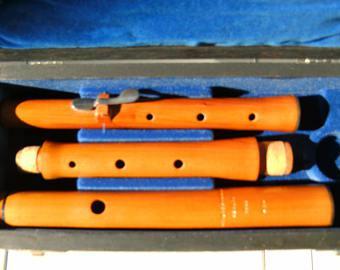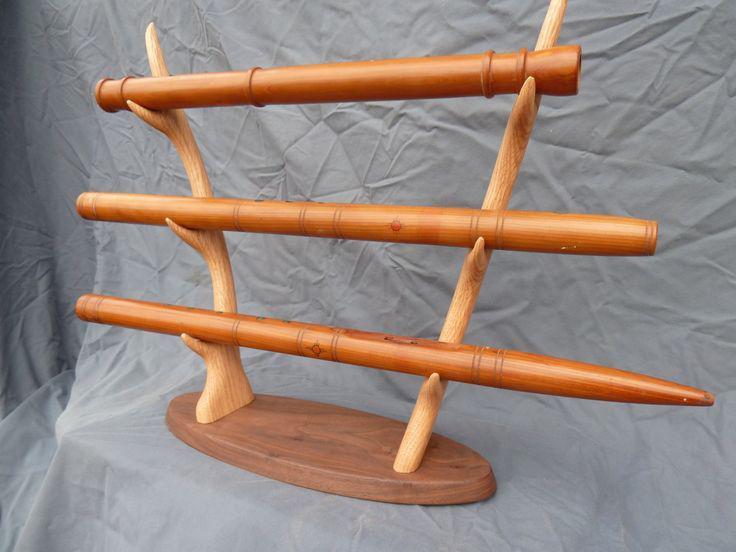The first image is the image on the left, the second image is the image on the right. Examine the images to the left and right. Is the description "In the right image, the instruments are displayed horizontally." accurate? Answer yes or no. Yes. The first image is the image on the left, the second image is the image on the right. Assess this claim about the two images: "In the image to the right, three parts of a flute are held horizontally.". Correct or not? Answer yes or no. Yes. 